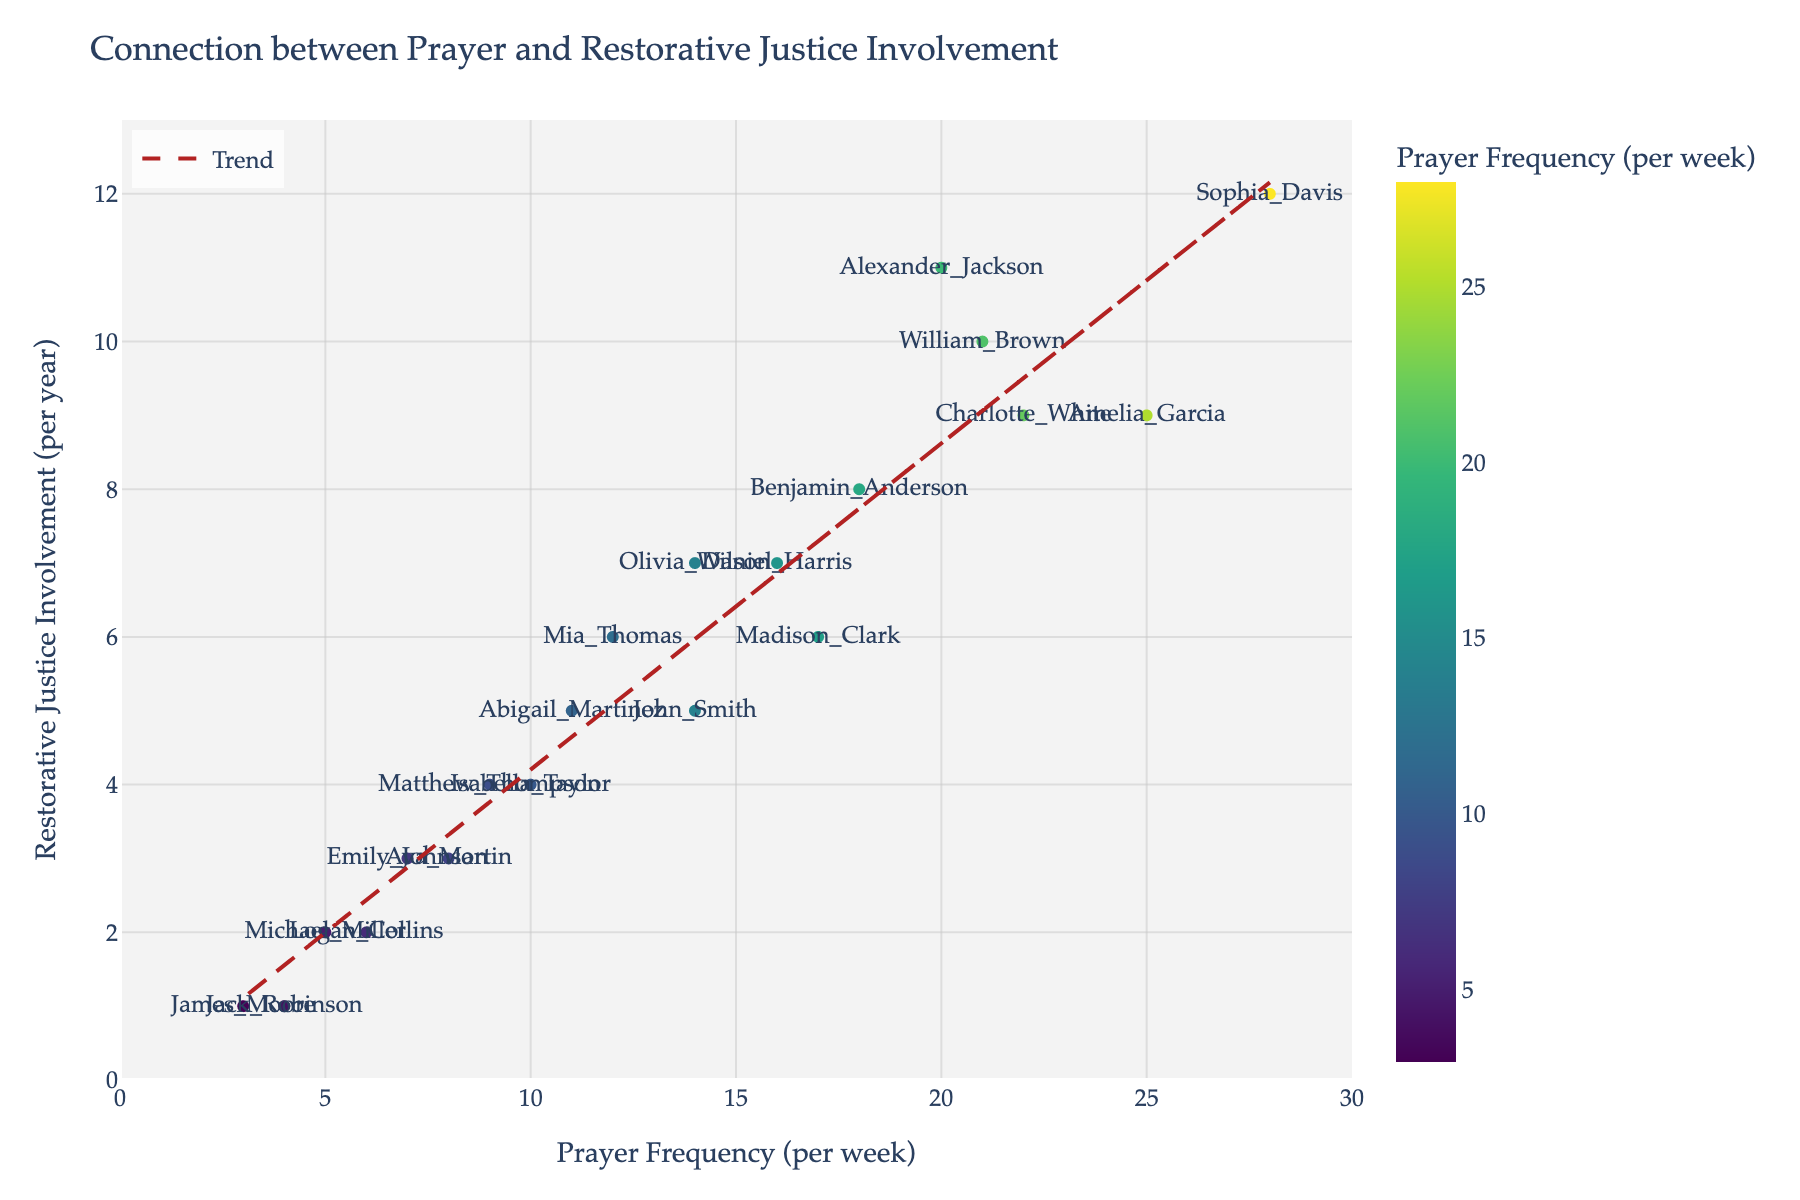What's the title of the plot? The title is usually displayed at the top of the plot. By observing the top portion of the figure, we can easily identify the title.
Answer: Connection between Prayer and Restorative Justice Involvement How many individuals are represented in the scatter plot? The number of individuals can be determined by counting the distinct data points on the scatter plot.
Answer: 20 Which individual prays the most frequently per week? To find the individual who prays the most frequently, locate the point with the highest x-axis value (Prayer Frequency).
Answer: Sophia Davis Which individual has the lowest involvement in restorative justice initiatives per year? To find the individual with the lowest involvement, locate the point with the smallest y-axis value (Restorative Justice Involvement).
Answer: James Moore What is the general trend between prayer frequency and involvement in restorative justice initiatives? The trend can be determined by the slope and direction of the trend line added to the plot. The direction shows whether there's a positive or negative correlation.
Answer: Positive correlation Which individuals have exactly 14 prayers per week? Identify the data points corresponding to the x-axis value of 14 and note the individual names associated.
Answer: John Smith, Olivia Wilson Compare the involvement in restorative justice initiatives of the individuals who pray 7 times per week and 25 times per week. Locate the points for 7 and 25 prayers per week and compare their y-axis values.
Answer: Emily Johnson (3) vs. Amelia Garcia (9) On average, how often do individuals who pray more than 15 times per week get involved in restorative justice initiatives? Calculate the average involvement for individuals with prayer frequencies greater than 15 by summing their involvement values and dividing by the count of such individuals.
Answer: (10 + 12 + 8 + 11 + 9) / 5 = 10 Is there anyone who prays less than 5 times a week but has an involvement rate of more than 1 restorative justice initiative per year? Check the scatter plot for individuals with x-axis values less than 5 and y-axis values greater than 1 to see if any exist.
Answer: No Who is more involved in restorative justice initiatives, Michael Miller or Madison Clark? Locate the points for Michael Miller and Madison Clark and compare their y-axis values (Involvement).
Answer: Madison Clark 